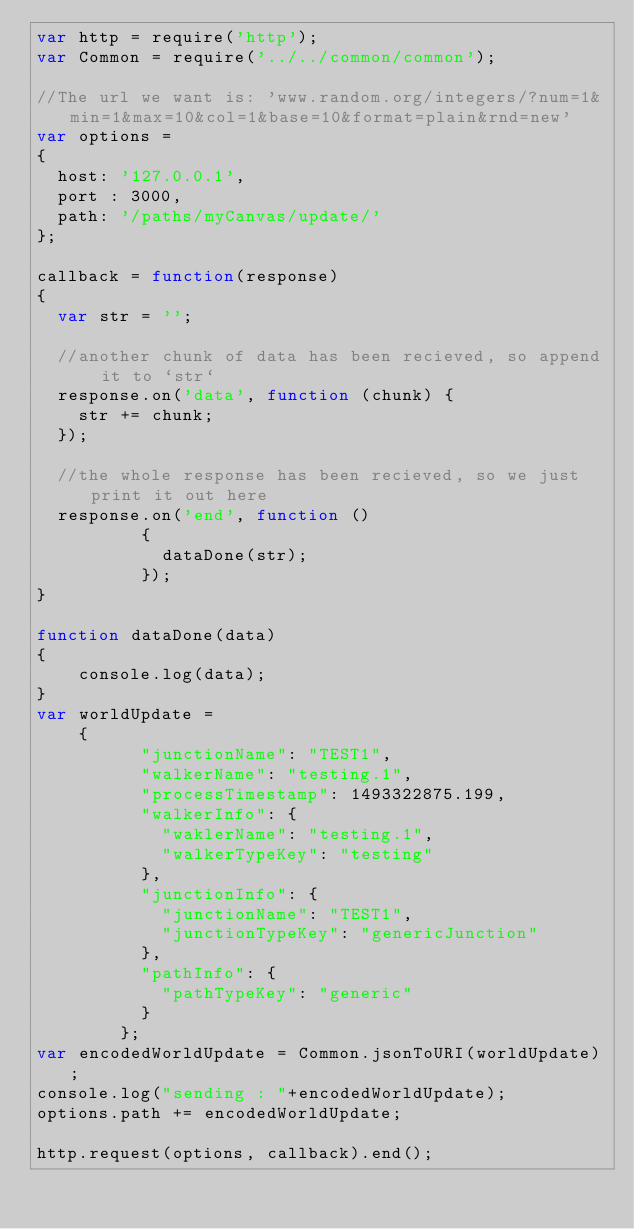Convert code to text. <code><loc_0><loc_0><loc_500><loc_500><_JavaScript_>var http = require('http');
var Common = require('../../common/common');

//The url we want is: 'www.random.org/integers/?num=1&min=1&max=10&col=1&base=10&format=plain&rnd=new'
var options =
{
  host: '127.0.0.1',
  port : 3000,
  path: '/paths/myCanvas/update/'
};

callback = function(response)
{
  var str = '';

  //another chunk of data has been recieved, so append it to `str`
  response.on('data', function (chunk) {
    str += chunk;
  });

  //the whole response has been recieved, so we just print it out here
  response.on('end', function ()
		  {
	  		dataDone(str);
		  });
}

function dataDone(data)
{
	console.log(data);
}
var worldUpdate = 
	{
		  "junctionName": "TEST1",
		  "walkerName": "testing.1",
		  "processTimestamp": 1493322875.199,
		  "walkerInfo": {
		    "waklerName": "testing.1",
		    "walkerTypeKey": "testing"
		  },
		  "junctionInfo": {
		    "junctionName": "TEST1",
		    "junctionTypeKey": "genericJunction"
		  },
		  "pathInfo": {
		    "pathTypeKey": "generic"
		  }
		};
var encodedWorldUpdate = Common.jsonToURI(worldUpdate);
console.log("sending : "+encodedWorldUpdate);
options.path += encodedWorldUpdate;

http.request(options, callback).end();
</code> 